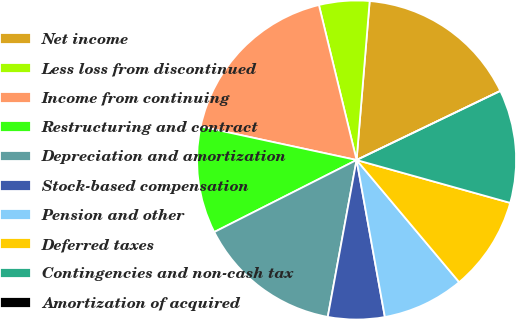Convert chart to OTSL. <chart><loc_0><loc_0><loc_500><loc_500><pie_chart><fcel>Net income<fcel>Less loss from discontinued<fcel>Income from continuing<fcel>Restructuring and contract<fcel>Depreciation and amortization<fcel>Stock-based compensation<fcel>Pension and other<fcel>Deferred taxes<fcel>Contingencies and non-cash tax<fcel>Amortization of acquired<nl><fcel>16.56%<fcel>5.1%<fcel>17.83%<fcel>10.83%<fcel>14.65%<fcel>5.73%<fcel>8.28%<fcel>9.55%<fcel>11.46%<fcel>0.0%<nl></chart> 